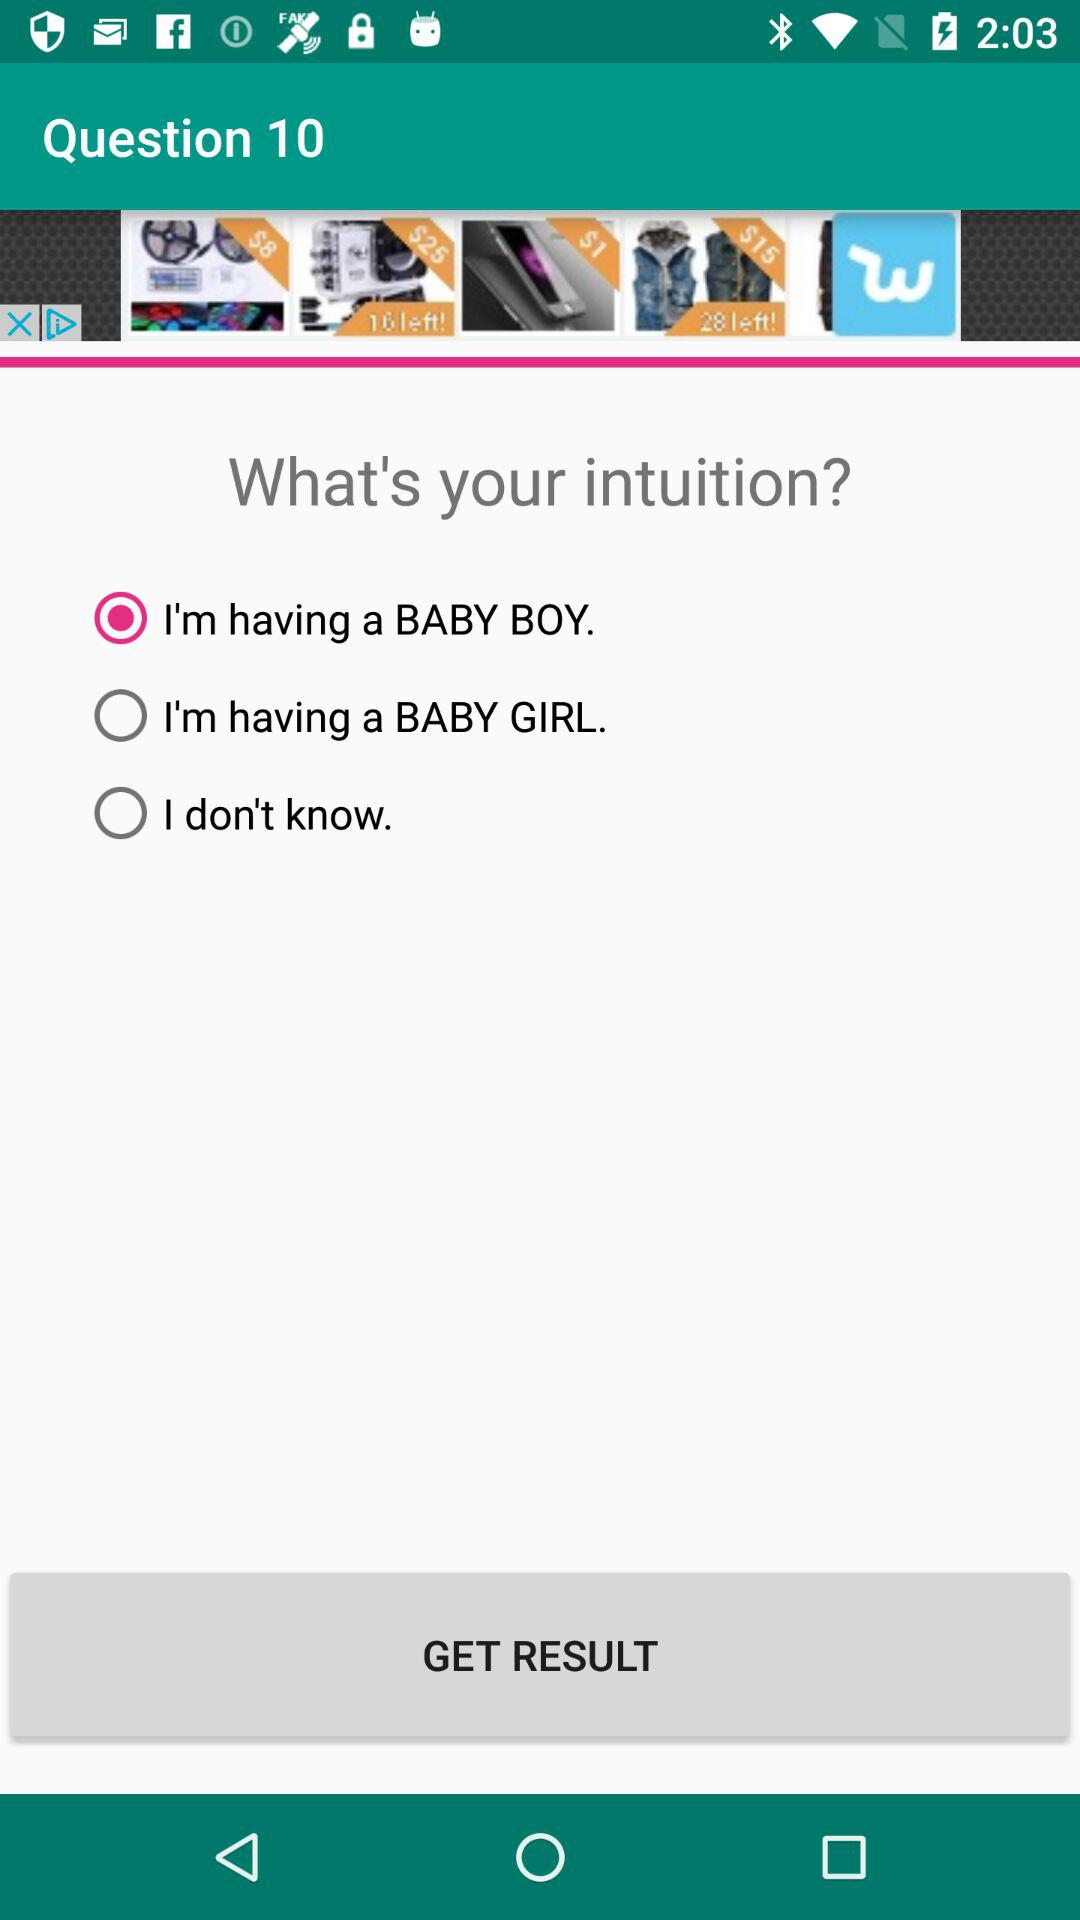Which option is selected for "What's your intuition?"? The selected option is "I'm having a BABY BOY". 